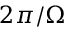Convert formula to latex. <formula><loc_0><loc_0><loc_500><loc_500>2 \pi / \Omega</formula> 